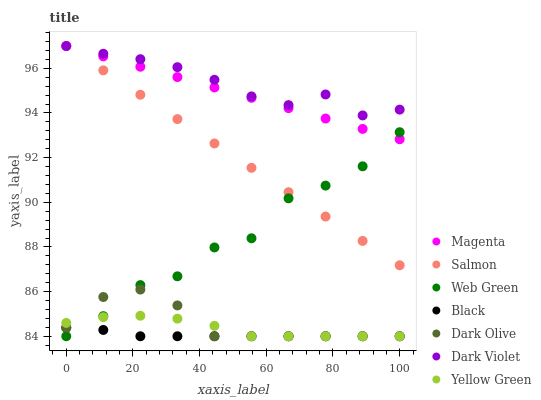Does Black have the minimum area under the curve?
Answer yes or no. Yes. Does Dark Violet have the maximum area under the curve?
Answer yes or no. Yes. Does Dark Olive have the minimum area under the curve?
Answer yes or no. No. Does Dark Olive have the maximum area under the curve?
Answer yes or no. No. Is Salmon the smoothest?
Answer yes or no. Yes. Is Web Green the roughest?
Answer yes or no. Yes. Is Dark Olive the smoothest?
Answer yes or no. No. Is Dark Olive the roughest?
Answer yes or no. No. Does Yellow Green have the lowest value?
Answer yes or no. Yes. Does Salmon have the lowest value?
Answer yes or no. No. Does Magenta have the highest value?
Answer yes or no. Yes. Does Dark Olive have the highest value?
Answer yes or no. No. Is Dark Olive less than Salmon?
Answer yes or no. Yes. Is Magenta greater than Black?
Answer yes or no. Yes. Does Yellow Green intersect Web Green?
Answer yes or no. Yes. Is Yellow Green less than Web Green?
Answer yes or no. No. Is Yellow Green greater than Web Green?
Answer yes or no. No. Does Dark Olive intersect Salmon?
Answer yes or no. No. 